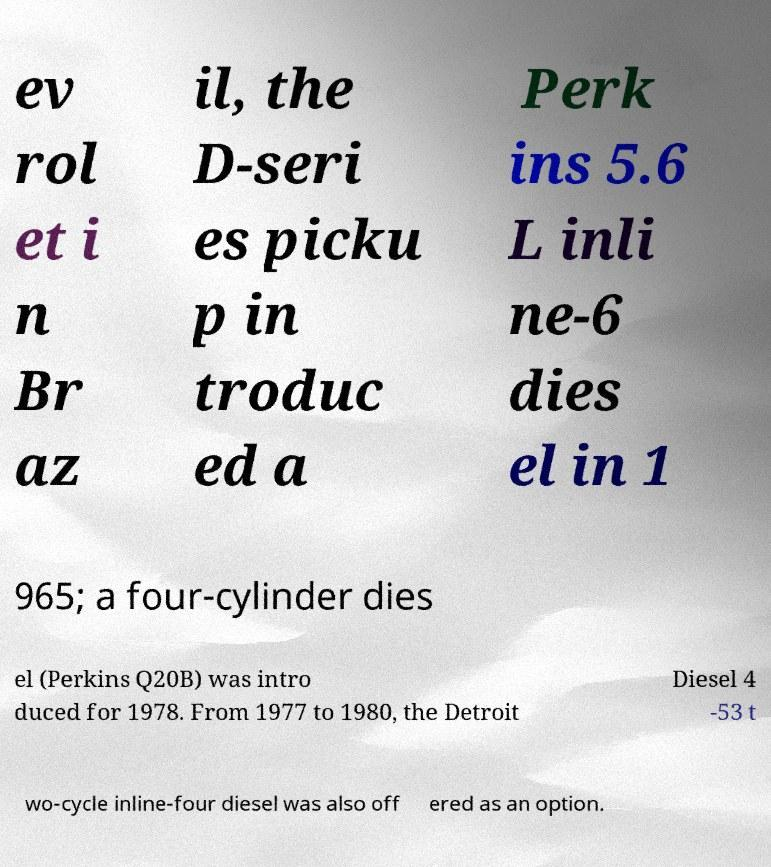What messages or text are displayed in this image? I need them in a readable, typed format. ev rol et i n Br az il, the D-seri es picku p in troduc ed a Perk ins 5.6 L inli ne-6 dies el in 1 965; a four-cylinder dies el (Perkins Q20B) was intro duced for 1978. From 1977 to 1980, the Detroit Diesel 4 -53 t wo-cycle inline-four diesel was also off ered as an option. 